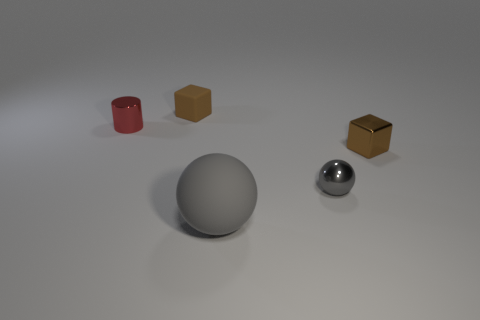Add 3 big green metallic blocks. How many objects exist? 8 Subtract all cylinders. How many objects are left? 4 Subtract all large yellow blocks. Subtract all gray things. How many objects are left? 3 Add 5 small brown blocks. How many small brown blocks are left? 7 Add 4 big gray objects. How many big gray objects exist? 5 Subtract 0 purple cylinders. How many objects are left? 5 